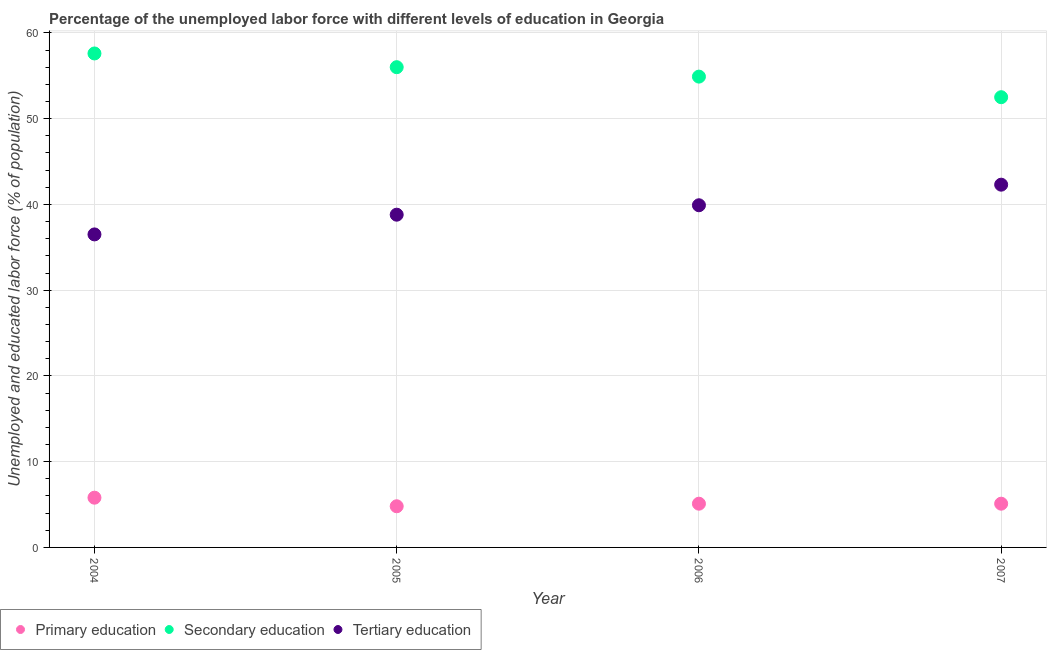Is the number of dotlines equal to the number of legend labels?
Keep it short and to the point. Yes. What is the percentage of labor force who received tertiary education in 2005?
Your answer should be compact. 38.8. Across all years, what is the maximum percentage of labor force who received primary education?
Your response must be concise. 5.8. Across all years, what is the minimum percentage of labor force who received primary education?
Provide a short and direct response. 4.8. In which year was the percentage of labor force who received tertiary education minimum?
Your response must be concise. 2004. What is the total percentage of labor force who received tertiary education in the graph?
Give a very brief answer. 157.5. What is the difference between the percentage of labor force who received secondary education in 2004 and that in 2007?
Offer a very short reply. 5.1. What is the difference between the percentage of labor force who received secondary education in 2006 and the percentage of labor force who received primary education in 2004?
Your answer should be compact. 49.1. What is the average percentage of labor force who received tertiary education per year?
Your answer should be very brief. 39.37. In the year 2005, what is the difference between the percentage of labor force who received tertiary education and percentage of labor force who received secondary education?
Keep it short and to the point. -17.2. In how many years, is the percentage of labor force who received secondary education greater than 56 %?
Give a very brief answer. 1. What is the ratio of the percentage of labor force who received primary education in 2005 to that in 2007?
Offer a very short reply. 0.94. Is the percentage of labor force who received primary education in 2004 less than that in 2007?
Offer a terse response. No. What is the difference between the highest and the second highest percentage of labor force who received primary education?
Your answer should be compact. 0.7. What is the difference between the highest and the lowest percentage of labor force who received tertiary education?
Give a very brief answer. 5.8. Is the sum of the percentage of labor force who received secondary education in 2005 and 2006 greater than the maximum percentage of labor force who received tertiary education across all years?
Offer a terse response. Yes. Does the percentage of labor force who received primary education monotonically increase over the years?
Your response must be concise. No. Is the percentage of labor force who received primary education strictly greater than the percentage of labor force who received secondary education over the years?
Your response must be concise. No. Is the percentage of labor force who received secondary education strictly less than the percentage of labor force who received tertiary education over the years?
Keep it short and to the point. No. What is the difference between two consecutive major ticks on the Y-axis?
Offer a terse response. 10. Where does the legend appear in the graph?
Provide a short and direct response. Bottom left. How are the legend labels stacked?
Your response must be concise. Horizontal. What is the title of the graph?
Give a very brief answer. Percentage of the unemployed labor force with different levels of education in Georgia. Does "Primary" appear as one of the legend labels in the graph?
Keep it short and to the point. No. What is the label or title of the X-axis?
Keep it short and to the point. Year. What is the label or title of the Y-axis?
Provide a succinct answer. Unemployed and educated labor force (% of population). What is the Unemployed and educated labor force (% of population) of Primary education in 2004?
Ensure brevity in your answer.  5.8. What is the Unemployed and educated labor force (% of population) of Secondary education in 2004?
Provide a succinct answer. 57.6. What is the Unemployed and educated labor force (% of population) of Tertiary education in 2004?
Provide a short and direct response. 36.5. What is the Unemployed and educated labor force (% of population) of Primary education in 2005?
Ensure brevity in your answer.  4.8. What is the Unemployed and educated labor force (% of population) in Secondary education in 2005?
Make the answer very short. 56. What is the Unemployed and educated labor force (% of population) in Tertiary education in 2005?
Your answer should be very brief. 38.8. What is the Unemployed and educated labor force (% of population) of Primary education in 2006?
Your answer should be compact. 5.1. What is the Unemployed and educated labor force (% of population) in Secondary education in 2006?
Offer a very short reply. 54.9. What is the Unemployed and educated labor force (% of population) in Tertiary education in 2006?
Make the answer very short. 39.9. What is the Unemployed and educated labor force (% of population) in Primary education in 2007?
Your answer should be very brief. 5.1. What is the Unemployed and educated labor force (% of population) of Secondary education in 2007?
Your response must be concise. 52.5. What is the Unemployed and educated labor force (% of population) of Tertiary education in 2007?
Offer a very short reply. 42.3. Across all years, what is the maximum Unemployed and educated labor force (% of population) in Primary education?
Offer a very short reply. 5.8. Across all years, what is the maximum Unemployed and educated labor force (% of population) in Secondary education?
Ensure brevity in your answer.  57.6. Across all years, what is the maximum Unemployed and educated labor force (% of population) in Tertiary education?
Make the answer very short. 42.3. Across all years, what is the minimum Unemployed and educated labor force (% of population) of Primary education?
Ensure brevity in your answer.  4.8. Across all years, what is the minimum Unemployed and educated labor force (% of population) of Secondary education?
Ensure brevity in your answer.  52.5. Across all years, what is the minimum Unemployed and educated labor force (% of population) in Tertiary education?
Your answer should be compact. 36.5. What is the total Unemployed and educated labor force (% of population) in Primary education in the graph?
Provide a succinct answer. 20.8. What is the total Unemployed and educated labor force (% of population) in Secondary education in the graph?
Ensure brevity in your answer.  221. What is the total Unemployed and educated labor force (% of population) in Tertiary education in the graph?
Ensure brevity in your answer.  157.5. What is the difference between the Unemployed and educated labor force (% of population) in Secondary education in 2004 and that in 2006?
Make the answer very short. 2.7. What is the difference between the Unemployed and educated labor force (% of population) of Primary education in 2004 and that in 2007?
Give a very brief answer. 0.7. What is the difference between the Unemployed and educated labor force (% of population) of Tertiary education in 2004 and that in 2007?
Provide a succinct answer. -5.8. What is the difference between the Unemployed and educated labor force (% of population) of Primary education in 2005 and that in 2006?
Your response must be concise. -0.3. What is the difference between the Unemployed and educated labor force (% of population) in Secondary education in 2005 and that in 2006?
Offer a very short reply. 1.1. What is the difference between the Unemployed and educated labor force (% of population) of Tertiary education in 2005 and that in 2006?
Your answer should be very brief. -1.1. What is the difference between the Unemployed and educated labor force (% of population) in Primary education in 2005 and that in 2007?
Offer a very short reply. -0.3. What is the difference between the Unemployed and educated labor force (% of population) of Secondary education in 2005 and that in 2007?
Your response must be concise. 3.5. What is the difference between the Unemployed and educated labor force (% of population) of Primary education in 2006 and that in 2007?
Offer a terse response. 0. What is the difference between the Unemployed and educated labor force (% of population) of Secondary education in 2006 and that in 2007?
Offer a terse response. 2.4. What is the difference between the Unemployed and educated labor force (% of population) in Tertiary education in 2006 and that in 2007?
Ensure brevity in your answer.  -2.4. What is the difference between the Unemployed and educated labor force (% of population) of Primary education in 2004 and the Unemployed and educated labor force (% of population) of Secondary education in 2005?
Make the answer very short. -50.2. What is the difference between the Unemployed and educated labor force (% of population) in Primary education in 2004 and the Unemployed and educated labor force (% of population) in Tertiary education in 2005?
Ensure brevity in your answer.  -33. What is the difference between the Unemployed and educated labor force (% of population) of Primary education in 2004 and the Unemployed and educated labor force (% of population) of Secondary education in 2006?
Make the answer very short. -49.1. What is the difference between the Unemployed and educated labor force (% of population) of Primary education in 2004 and the Unemployed and educated labor force (% of population) of Tertiary education in 2006?
Your answer should be compact. -34.1. What is the difference between the Unemployed and educated labor force (% of population) of Secondary education in 2004 and the Unemployed and educated labor force (% of population) of Tertiary education in 2006?
Offer a very short reply. 17.7. What is the difference between the Unemployed and educated labor force (% of population) of Primary education in 2004 and the Unemployed and educated labor force (% of population) of Secondary education in 2007?
Provide a succinct answer. -46.7. What is the difference between the Unemployed and educated labor force (% of population) in Primary education in 2004 and the Unemployed and educated labor force (% of population) in Tertiary education in 2007?
Offer a very short reply. -36.5. What is the difference between the Unemployed and educated labor force (% of population) of Secondary education in 2004 and the Unemployed and educated labor force (% of population) of Tertiary education in 2007?
Give a very brief answer. 15.3. What is the difference between the Unemployed and educated labor force (% of population) in Primary education in 2005 and the Unemployed and educated labor force (% of population) in Secondary education in 2006?
Keep it short and to the point. -50.1. What is the difference between the Unemployed and educated labor force (% of population) in Primary education in 2005 and the Unemployed and educated labor force (% of population) in Tertiary education in 2006?
Offer a terse response. -35.1. What is the difference between the Unemployed and educated labor force (% of population) of Secondary education in 2005 and the Unemployed and educated labor force (% of population) of Tertiary education in 2006?
Your response must be concise. 16.1. What is the difference between the Unemployed and educated labor force (% of population) of Primary education in 2005 and the Unemployed and educated labor force (% of population) of Secondary education in 2007?
Your answer should be very brief. -47.7. What is the difference between the Unemployed and educated labor force (% of population) in Primary education in 2005 and the Unemployed and educated labor force (% of population) in Tertiary education in 2007?
Offer a terse response. -37.5. What is the difference between the Unemployed and educated labor force (% of population) of Primary education in 2006 and the Unemployed and educated labor force (% of population) of Secondary education in 2007?
Your answer should be compact. -47.4. What is the difference between the Unemployed and educated labor force (% of population) of Primary education in 2006 and the Unemployed and educated labor force (% of population) of Tertiary education in 2007?
Give a very brief answer. -37.2. What is the difference between the Unemployed and educated labor force (% of population) in Secondary education in 2006 and the Unemployed and educated labor force (% of population) in Tertiary education in 2007?
Your response must be concise. 12.6. What is the average Unemployed and educated labor force (% of population) of Primary education per year?
Make the answer very short. 5.2. What is the average Unemployed and educated labor force (% of population) in Secondary education per year?
Keep it short and to the point. 55.25. What is the average Unemployed and educated labor force (% of population) in Tertiary education per year?
Keep it short and to the point. 39.38. In the year 2004, what is the difference between the Unemployed and educated labor force (% of population) in Primary education and Unemployed and educated labor force (% of population) in Secondary education?
Your response must be concise. -51.8. In the year 2004, what is the difference between the Unemployed and educated labor force (% of population) of Primary education and Unemployed and educated labor force (% of population) of Tertiary education?
Offer a very short reply. -30.7. In the year 2004, what is the difference between the Unemployed and educated labor force (% of population) of Secondary education and Unemployed and educated labor force (% of population) of Tertiary education?
Your answer should be compact. 21.1. In the year 2005, what is the difference between the Unemployed and educated labor force (% of population) of Primary education and Unemployed and educated labor force (% of population) of Secondary education?
Your answer should be very brief. -51.2. In the year 2005, what is the difference between the Unemployed and educated labor force (% of population) in Primary education and Unemployed and educated labor force (% of population) in Tertiary education?
Offer a very short reply. -34. In the year 2006, what is the difference between the Unemployed and educated labor force (% of population) in Primary education and Unemployed and educated labor force (% of population) in Secondary education?
Provide a short and direct response. -49.8. In the year 2006, what is the difference between the Unemployed and educated labor force (% of population) in Primary education and Unemployed and educated labor force (% of population) in Tertiary education?
Ensure brevity in your answer.  -34.8. In the year 2007, what is the difference between the Unemployed and educated labor force (% of population) of Primary education and Unemployed and educated labor force (% of population) of Secondary education?
Offer a terse response. -47.4. In the year 2007, what is the difference between the Unemployed and educated labor force (% of population) in Primary education and Unemployed and educated labor force (% of population) in Tertiary education?
Offer a terse response. -37.2. What is the ratio of the Unemployed and educated labor force (% of population) of Primary education in 2004 to that in 2005?
Give a very brief answer. 1.21. What is the ratio of the Unemployed and educated labor force (% of population) of Secondary education in 2004 to that in 2005?
Offer a terse response. 1.03. What is the ratio of the Unemployed and educated labor force (% of population) of Tertiary education in 2004 to that in 2005?
Offer a very short reply. 0.94. What is the ratio of the Unemployed and educated labor force (% of population) of Primary education in 2004 to that in 2006?
Your response must be concise. 1.14. What is the ratio of the Unemployed and educated labor force (% of population) of Secondary education in 2004 to that in 2006?
Keep it short and to the point. 1.05. What is the ratio of the Unemployed and educated labor force (% of population) of Tertiary education in 2004 to that in 2006?
Your answer should be very brief. 0.91. What is the ratio of the Unemployed and educated labor force (% of population) in Primary education in 2004 to that in 2007?
Give a very brief answer. 1.14. What is the ratio of the Unemployed and educated labor force (% of population) of Secondary education in 2004 to that in 2007?
Keep it short and to the point. 1.1. What is the ratio of the Unemployed and educated labor force (% of population) in Tertiary education in 2004 to that in 2007?
Provide a succinct answer. 0.86. What is the ratio of the Unemployed and educated labor force (% of population) of Primary education in 2005 to that in 2006?
Offer a terse response. 0.94. What is the ratio of the Unemployed and educated labor force (% of population) in Secondary education in 2005 to that in 2006?
Provide a short and direct response. 1.02. What is the ratio of the Unemployed and educated labor force (% of population) in Tertiary education in 2005 to that in 2006?
Keep it short and to the point. 0.97. What is the ratio of the Unemployed and educated labor force (% of population) of Primary education in 2005 to that in 2007?
Your response must be concise. 0.94. What is the ratio of the Unemployed and educated labor force (% of population) in Secondary education in 2005 to that in 2007?
Offer a very short reply. 1.07. What is the ratio of the Unemployed and educated labor force (% of population) of Tertiary education in 2005 to that in 2007?
Keep it short and to the point. 0.92. What is the ratio of the Unemployed and educated labor force (% of population) of Secondary education in 2006 to that in 2007?
Ensure brevity in your answer.  1.05. What is the ratio of the Unemployed and educated labor force (% of population) of Tertiary education in 2006 to that in 2007?
Your response must be concise. 0.94. What is the difference between the highest and the second highest Unemployed and educated labor force (% of population) of Secondary education?
Keep it short and to the point. 1.6. What is the difference between the highest and the second highest Unemployed and educated labor force (% of population) of Tertiary education?
Give a very brief answer. 2.4. 